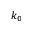Convert formula to latex. <formula><loc_0><loc_0><loc_500><loc_500>k _ { 0 }</formula> 